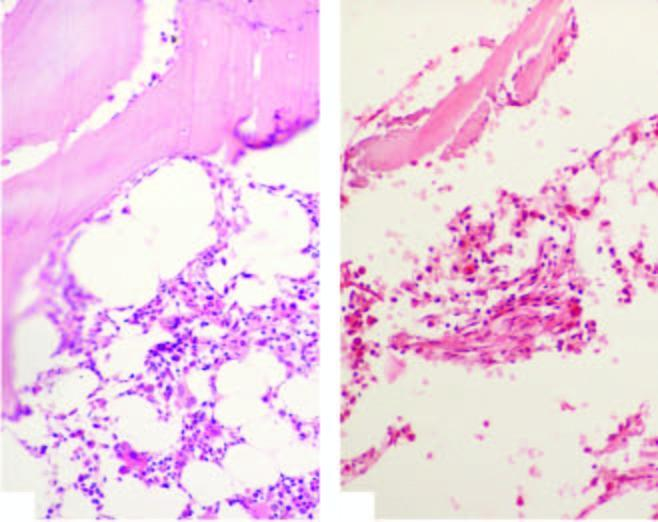s one marrow trephine biopsy in aplastic anaemia contrasted against normal cellular marrow?
Answer the question using a single word or phrase. Yes 